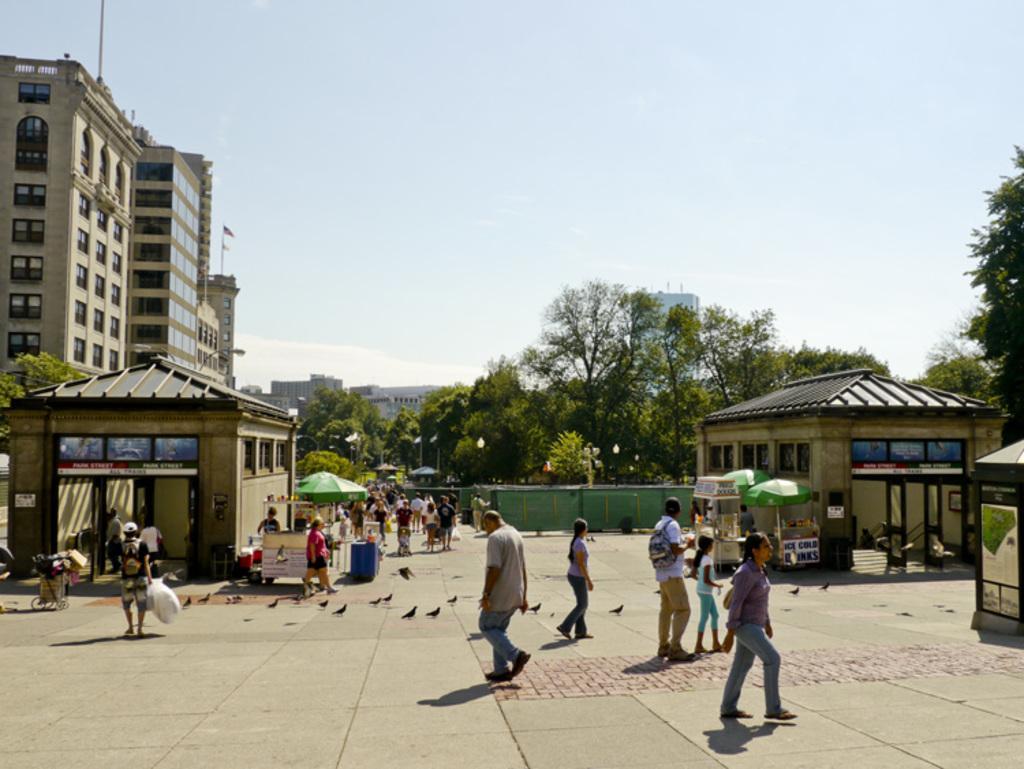How would you summarize this image in a sentence or two? In this image there are persons standing and walking, there are birds, there are tents and boards with some text written on the it and there are houses. In the background there are trees and buildings and we can see clouds in the sky. In the center there are trolleys. 